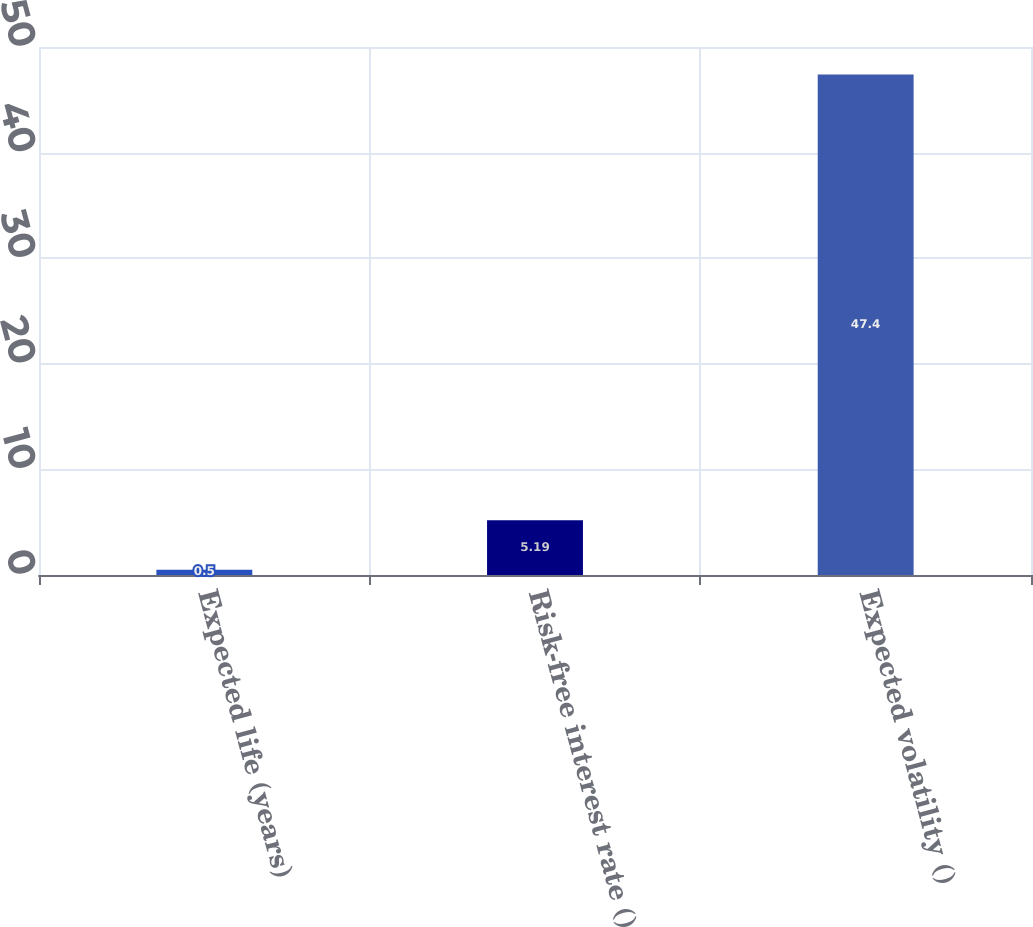Convert chart to OTSL. <chart><loc_0><loc_0><loc_500><loc_500><bar_chart><fcel>Expected life (years)<fcel>Risk-free interest rate ()<fcel>Expected volatility ()<nl><fcel>0.5<fcel>5.19<fcel>47.4<nl></chart> 